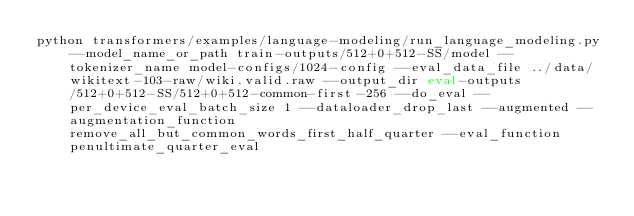<code> <loc_0><loc_0><loc_500><loc_500><_Bash_>python transformers/examples/language-modeling/run_language_modeling.py --model_name_or_path train-outputs/512+0+512-SS/model --tokenizer_name model-configs/1024-config --eval_data_file ../data/wikitext-103-raw/wiki.valid.raw --output_dir eval-outputs/512+0+512-SS/512+0+512-common-first-256 --do_eval --per_device_eval_batch_size 1 --dataloader_drop_last --augmented --augmentation_function remove_all_but_common_words_first_half_quarter --eval_function penultimate_quarter_eval</code> 